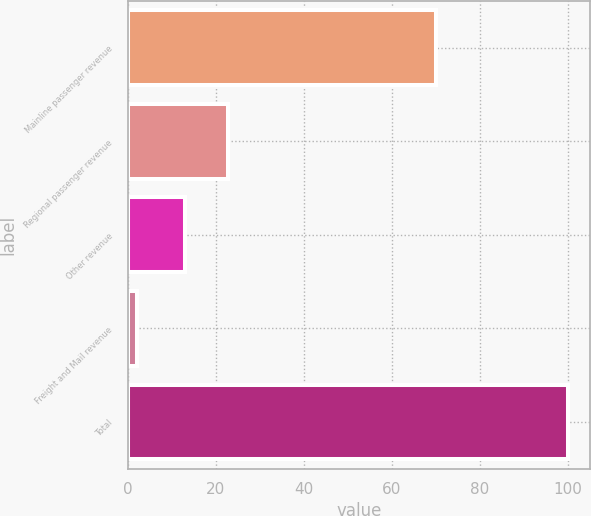Convert chart to OTSL. <chart><loc_0><loc_0><loc_500><loc_500><bar_chart><fcel>Mainline passenger revenue<fcel>Regional passenger revenue<fcel>Other revenue<fcel>Freight and Mail revenue<fcel>Total<nl><fcel>70<fcel>22.8<fcel>13<fcel>2<fcel>100<nl></chart> 